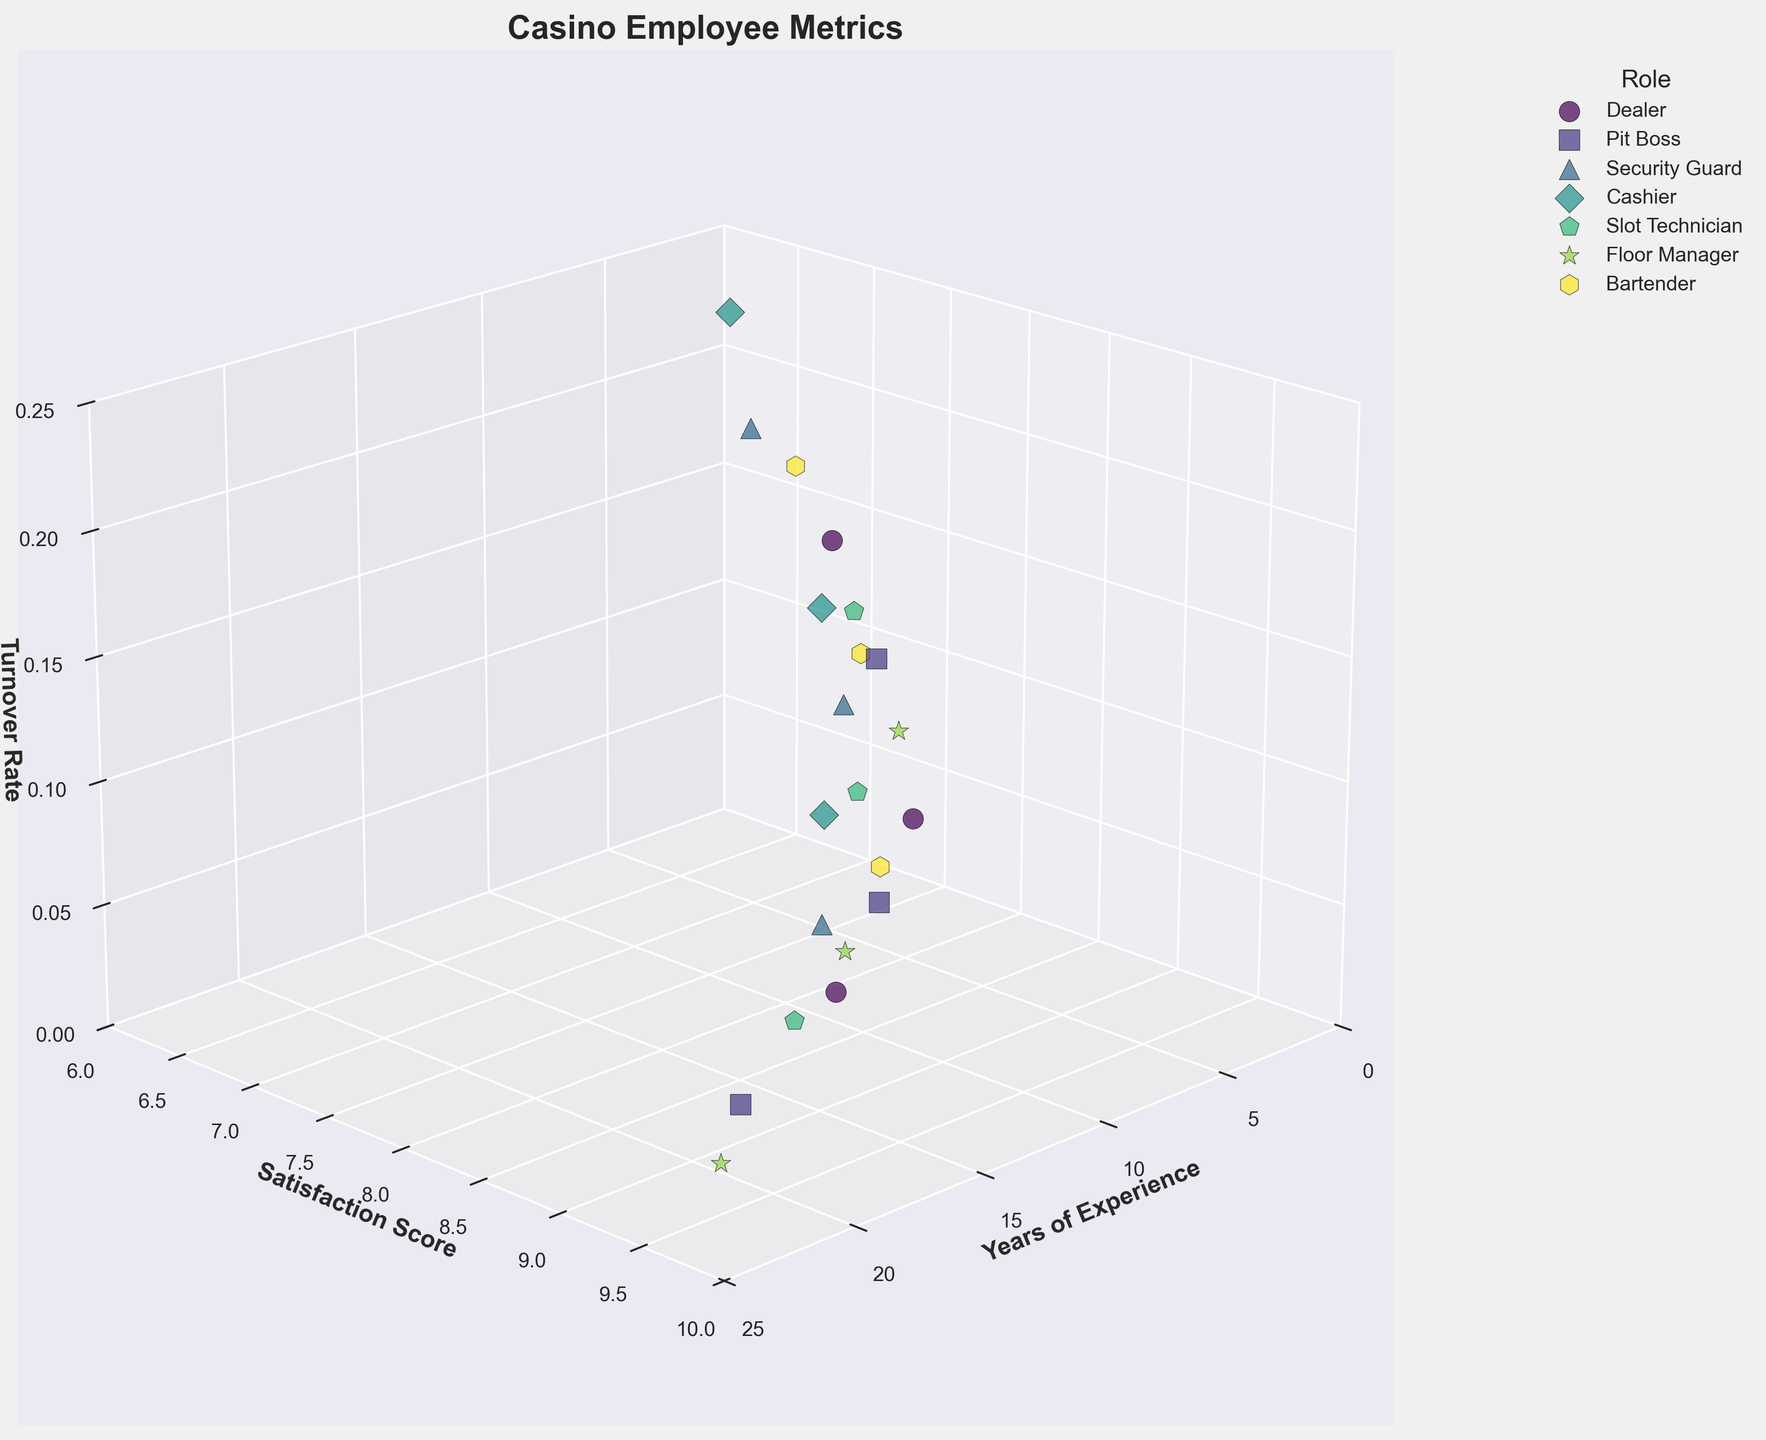How many roles have been plotted in the figure? The figure legend shows the different roles that have been plotted. By counting the unique roles listed in the legend, we can determine the number of roles.
Answer: 6 What is the title of the figure? The title of the figure is written at the top of the plot and clearly labels what the plot is about.
Answer: Casino Employee Metrics Which axis represents the Years of Experience? By looking at the axis labels, we can identify that the axis labeled "Years of Experience" represents this metric.
Answer: X-axis Which role has the highest satisfaction score? By examining the Y-axis (which represents Satisfaction Score) and finding the highest value, we can then look for the corresponding role in the scatter plot and the legend.
Answer: Floor Manager What is the general trend between Years of Experience and Turnover Rate? By observing the scatter plot and the Z-axis (which represents Turnover Rate), we can see if turnover rates tend to increase, decrease, or stay the same as years of experience increase.
Answer: Generally decreases How does the satisfaction score of dealers compare with that of pit bosses? We can compare the points representing dealers and pit bosses on the Y-axis, which shows the Satisfaction Score, to see which tends to be higher.
Answer: Pit bosses have higher scores What is the relationship between satisfaction score and turnover rate? By observing the scatter plot and correlating points on the Z-axis (Turnover Rate) with their respective points on the Y-axis (Satisfaction Score), we can infer if higher satisfaction scores associate with higher or lower turnover rates.
Answer: Higher satisfaction scores generally associate with lower turnover rates Which role appears to have the lowest turnover rate for employees with over 10 years of experience? By focusing on the data points that represent over 10 years of experience, we can compare the Z-axis values among different roles to find the lowest turnover rate.
Answer: Floor Manager Which role has the most significant spread in satisfaction scores? By looking at the range of satisfaction scores (Y-axis) for each role, we can see which role has the widest spread from the lowest to the highest score.
Answer: Security Guard Considering years of experience and turnover rate, which role appears to have the best balance for employee retention? By looking at roles with higher years of experience and lower turnover rates, we can determine which role has the best balance of these two metrics.
Answer: Floor Manager 